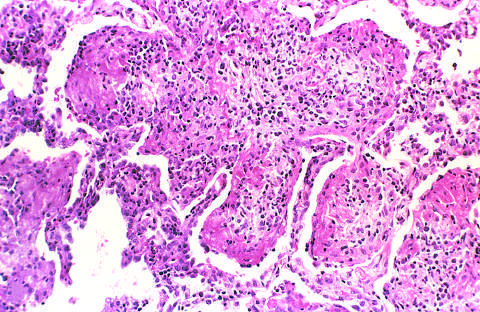s early organization of intraalveolar exudate seen?
Answer the question using a single word or phrase. Yes 